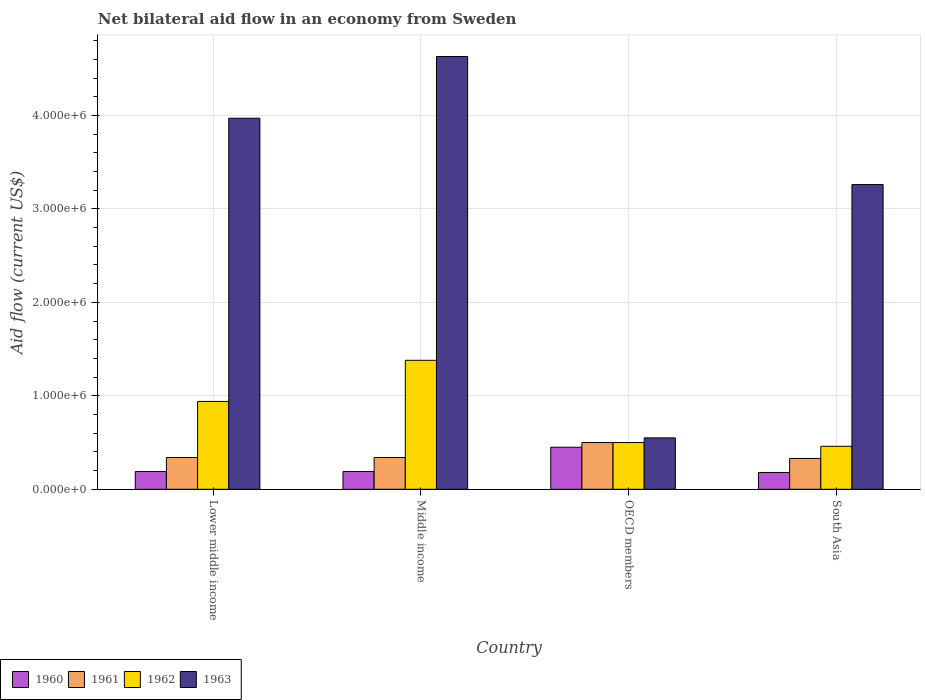How many different coloured bars are there?
Keep it short and to the point. 4. How many groups of bars are there?
Make the answer very short. 4. Are the number of bars on each tick of the X-axis equal?
Give a very brief answer. Yes. How many bars are there on the 1st tick from the left?
Give a very brief answer. 4. How many bars are there on the 2nd tick from the right?
Offer a terse response. 4. What is the label of the 2nd group of bars from the left?
Your answer should be compact. Middle income. Across all countries, what is the maximum net bilateral aid flow in 1961?
Offer a very short reply. 5.00e+05. Across all countries, what is the minimum net bilateral aid flow in 1961?
Provide a short and direct response. 3.30e+05. In which country was the net bilateral aid flow in 1962 maximum?
Keep it short and to the point. Middle income. What is the total net bilateral aid flow in 1963 in the graph?
Make the answer very short. 1.24e+07. What is the difference between the net bilateral aid flow in 1963 in Lower middle income and that in Middle income?
Offer a very short reply. -6.60e+05. What is the average net bilateral aid flow in 1960 per country?
Ensure brevity in your answer.  2.52e+05. What is the ratio of the net bilateral aid flow in 1963 in Middle income to that in OECD members?
Make the answer very short. 8.42. What is the difference between the highest and the second highest net bilateral aid flow in 1963?
Offer a terse response. 1.37e+06. What is the difference between the highest and the lowest net bilateral aid flow in 1961?
Your response must be concise. 1.70e+05. In how many countries, is the net bilateral aid flow in 1963 greater than the average net bilateral aid flow in 1963 taken over all countries?
Your response must be concise. 3. What does the 4th bar from the left in OECD members represents?
Your answer should be very brief. 1963. What does the 2nd bar from the right in Middle income represents?
Offer a very short reply. 1962. What is the difference between two consecutive major ticks on the Y-axis?
Your answer should be compact. 1.00e+06. Does the graph contain any zero values?
Your answer should be compact. No. How many legend labels are there?
Keep it short and to the point. 4. What is the title of the graph?
Give a very brief answer. Net bilateral aid flow in an economy from Sweden. What is the label or title of the X-axis?
Provide a short and direct response. Country. What is the Aid flow (current US$) in 1960 in Lower middle income?
Provide a succinct answer. 1.90e+05. What is the Aid flow (current US$) of 1962 in Lower middle income?
Your response must be concise. 9.40e+05. What is the Aid flow (current US$) of 1963 in Lower middle income?
Keep it short and to the point. 3.97e+06. What is the Aid flow (current US$) of 1960 in Middle income?
Make the answer very short. 1.90e+05. What is the Aid flow (current US$) of 1962 in Middle income?
Give a very brief answer. 1.38e+06. What is the Aid flow (current US$) in 1963 in Middle income?
Make the answer very short. 4.63e+06. What is the Aid flow (current US$) of 1960 in OECD members?
Offer a terse response. 4.50e+05. What is the Aid flow (current US$) in 1961 in OECD members?
Offer a very short reply. 5.00e+05. What is the Aid flow (current US$) in 1960 in South Asia?
Offer a very short reply. 1.80e+05. What is the Aid flow (current US$) in 1961 in South Asia?
Your response must be concise. 3.30e+05. What is the Aid flow (current US$) of 1963 in South Asia?
Your answer should be compact. 3.26e+06. Across all countries, what is the maximum Aid flow (current US$) of 1961?
Your response must be concise. 5.00e+05. Across all countries, what is the maximum Aid flow (current US$) of 1962?
Make the answer very short. 1.38e+06. Across all countries, what is the maximum Aid flow (current US$) in 1963?
Ensure brevity in your answer.  4.63e+06. Across all countries, what is the minimum Aid flow (current US$) of 1960?
Keep it short and to the point. 1.80e+05. Across all countries, what is the minimum Aid flow (current US$) in 1962?
Provide a succinct answer. 4.60e+05. Across all countries, what is the minimum Aid flow (current US$) of 1963?
Offer a terse response. 5.50e+05. What is the total Aid flow (current US$) in 1960 in the graph?
Your answer should be compact. 1.01e+06. What is the total Aid flow (current US$) of 1961 in the graph?
Provide a short and direct response. 1.51e+06. What is the total Aid flow (current US$) of 1962 in the graph?
Give a very brief answer. 3.28e+06. What is the total Aid flow (current US$) of 1963 in the graph?
Offer a very short reply. 1.24e+07. What is the difference between the Aid flow (current US$) in 1960 in Lower middle income and that in Middle income?
Your response must be concise. 0. What is the difference between the Aid flow (current US$) in 1962 in Lower middle income and that in Middle income?
Provide a short and direct response. -4.40e+05. What is the difference between the Aid flow (current US$) in 1963 in Lower middle income and that in Middle income?
Provide a short and direct response. -6.60e+05. What is the difference between the Aid flow (current US$) in 1960 in Lower middle income and that in OECD members?
Give a very brief answer. -2.60e+05. What is the difference between the Aid flow (current US$) in 1961 in Lower middle income and that in OECD members?
Your response must be concise. -1.60e+05. What is the difference between the Aid flow (current US$) of 1962 in Lower middle income and that in OECD members?
Keep it short and to the point. 4.40e+05. What is the difference between the Aid flow (current US$) in 1963 in Lower middle income and that in OECD members?
Keep it short and to the point. 3.42e+06. What is the difference between the Aid flow (current US$) in 1960 in Lower middle income and that in South Asia?
Give a very brief answer. 10000. What is the difference between the Aid flow (current US$) in 1961 in Lower middle income and that in South Asia?
Provide a succinct answer. 10000. What is the difference between the Aid flow (current US$) of 1963 in Lower middle income and that in South Asia?
Keep it short and to the point. 7.10e+05. What is the difference between the Aid flow (current US$) of 1960 in Middle income and that in OECD members?
Your response must be concise. -2.60e+05. What is the difference between the Aid flow (current US$) in 1961 in Middle income and that in OECD members?
Provide a succinct answer. -1.60e+05. What is the difference between the Aid flow (current US$) in 1962 in Middle income and that in OECD members?
Provide a succinct answer. 8.80e+05. What is the difference between the Aid flow (current US$) in 1963 in Middle income and that in OECD members?
Provide a succinct answer. 4.08e+06. What is the difference between the Aid flow (current US$) of 1961 in Middle income and that in South Asia?
Your answer should be compact. 10000. What is the difference between the Aid flow (current US$) in 1962 in Middle income and that in South Asia?
Your answer should be compact. 9.20e+05. What is the difference between the Aid flow (current US$) in 1963 in Middle income and that in South Asia?
Give a very brief answer. 1.37e+06. What is the difference between the Aid flow (current US$) of 1962 in OECD members and that in South Asia?
Offer a very short reply. 4.00e+04. What is the difference between the Aid flow (current US$) of 1963 in OECD members and that in South Asia?
Make the answer very short. -2.71e+06. What is the difference between the Aid flow (current US$) in 1960 in Lower middle income and the Aid flow (current US$) in 1962 in Middle income?
Your answer should be compact. -1.19e+06. What is the difference between the Aid flow (current US$) in 1960 in Lower middle income and the Aid flow (current US$) in 1963 in Middle income?
Ensure brevity in your answer.  -4.44e+06. What is the difference between the Aid flow (current US$) of 1961 in Lower middle income and the Aid flow (current US$) of 1962 in Middle income?
Offer a very short reply. -1.04e+06. What is the difference between the Aid flow (current US$) in 1961 in Lower middle income and the Aid flow (current US$) in 1963 in Middle income?
Your answer should be compact. -4.29e+06. What is the difference between the Aid flow (current US$) of 1962 in Lower middle income and the Aid flow (current US$) of 1963 in Middle income?
Make the answer very short. -3.69e+06. What is the difference between the Aid flow (current US$) in 1960 in Lower middle income and the Aid flow (current US$) in 1961 in OECD members?
Your response must be concise. -3.10e+05. What is the difference between the Aid flow (current US$) of 1960 in Lower middle income and the Aid flow (current US$) of 1962 in OECD members?
Provide a short and direct response. -3.10e+05. What is the difference between the Aid flow (current US$) in 1960 in Lower middle income and the Aid flow (current US$) in 1963 in OECD members?
Provide a short and direct response. -3.60e+05. What is the difference between the Aid flow (current US$) in 1961 in Lower middle income and the Aid flow (current US$) in 1962 in OECD members?
Provide a short and direct response. -1.60e+05. What is the difference between the Aid flow (current US$) of 1960 in Lower middle income and the Aid flow (current US$) of 1961 in South Asia?
Provide a short and direct response. -1.40e+05. What is the difference between the Aid flow (current US$) in 1960 in Lower middle income and the Aid flow (current US$) in 1963 in South Asia?
Ensure brevity in your answer.  -3.07e+06. What is the difference between the Aid flow (current US$) in 1961 in Lower middle income and the Aid flow (current US$) in 1962 in South Asia?
Ensure brevity in your answer.  -1.20e+05. What is the difference between the Aid flow (current US$) in 1961 in Lower middle income and the Aid flow (current US$) in 1963 in South Asia?
Ensure brevity in your answer.  -2.92e+06. What is the difference between the Aid flow (current US$) in 1962 in Lower middle income and the Aid flow (current US$) in 1963 in South Asia?
Offer a terse response. -2.32e+06. What is the difference between the Aid flow (current US$) in 1960 in Middle income and the Aid flow (current US$) in 1961 in OECD members?
Your answer should be very brief. -3.10e+05. What is the difference between the Aid flow (current US$) in 1960 in Middle income and the Aid flow (current US$) in 1962 in OECD members?
Keep it short and to the point. -3.10e+05. What is the difference between the Aid flow (current US$) in 1960 in Middle income and the Aid flow (current US$) in 1963 in OECD members?
Make the answer very short. -3.60e+05. What is the difference between the Aid flow (current US$) in 1962 in Middle income and the Aid flow (current US$) in 1963 in OECD members?
Your answer should be compact. 8.30e+05. What is the difference between the Aid flow (current US$) in 1960 in Middle income and the Aid flow (current US$) in 1962 in South Asia?
Provide a succinct answer. -2.70e+05. What is the difference between the Aid flow (current US$) in 1960 in Middle income and the Aid flow (current US$) in 1963 in South Asia?
Ensure brevity in your answer.  -3.07e+06. What is the difference between the Aid flow (current US$) of 1961 in Middle income and the Aid flow (current US$) of 1962 in South Asia?
Offer a very short reply. -1.20e+05. What is the difference between the Aid flow (current US$) in 1961 in Middle income and the Aid flow (current US$) in 1963 in South Asia?
Give a very brief answer. -2.92e+06. What is the difference between the Aid flow (current US$) of 1962 in Middle income and the Aid flow (current US$) of 1963 in South Asia?
Offer a very short reply. -1.88e+06. What is the difference between the Aid flow (current US$) in 1960 in OECD members and the Aid flow (current US$) in 1962 in South Asia?
Keep it short and to the point. -10000. What is the difference between the Aid flow (current US$) of 1960 in OECD members and the Aid flow (current US$) of 1963 in South Asia?
Your response must be concise. -2.81e+06. What is the difference between the Aid flow (current US$) of 1961 in OECD members and the Aid flow (current US$) of 1962 in South Asia?
Your answer should be compact. 4.00e+04. What is the difference between the Aid flow (current US$) in 1961 in OECD members and the Aid flow (current US$) in 1963 in South Asia?
Provide a short and direct response. -2.76e+06. What is the difference between the Aid flow (current US$) of 1962 in OECD members and the Aid flow (current US$) of 1963 in South Asia?
Offer a very short reply. -2.76e+06. What is the average Aid flow (current US$) of 1960 per country?
Offer a very short reply. 2.52e+05. What is the average Aid flow (current US$) in 1961 per country?
Your response must be concise. 3.78e+05. What is the average Aid flow (current US$) of 1962 per country?
Keep it short and to the point. 8.20e+05. What is the average Aid flow (current US$) in 1963 per country?
Provide a short and direct response. 3.10e+06. What is the difference between the Aid flow (current US$) of 1960 and Aid flow (current US$) of 1962 in Lower middle income?
Offer a very short reply. -7.50e+05. What is the difference between the Aid flow (current US$) of 1960 and Aid flow (current US$) of 1963 in Lower middle income?
Provide a succinct answer. -3.78e+06. What is the difference between the Aid flow (current US$) of 1961 and Aid flow (current US$) of 1962 in Lower middle income?
Give a very brief answer. -6.00e+05. What is the difference between the Aid flow (current US$) in 1961 and Aid flow (current US$) in 1963 in Lower middle income?
Your response must be concise. -3.63e+06. What is the difference between the Aid flow (current US$) in 1962 and Aid flow (current US$) in 1963 in Lower middle income?
Keep it short and to the point. -3.03e+06. What is the difference between the Aid flow (current US$) of 1960 and Aid flow (current US$) of 1962 in Middle income?
Give a very brief answer. -1.19e+06. What is the difference between the Aid flow (current US$) of 1960 and Aid flow (current US$) of 1963 in Middle income?
Provide a succinct answer. -4.44e+06. What is the difference between the Aid flow (current US$) in 1961 and Aid flow (current US$) in 1962 in Middle income?
Make the answer very short. -1.04e+06. What is the difference between the Aid flow (current US$) of 1961 and Aid flow (current US$) of 1963 in Middle income?
Your response must be concise. -4.29e+06. What is the difference between the Aid flow (current US$) in 1962 and Aid flow (current US$) in 1963 in Middle income?
Give a very brief answer. -3.25e+06. What is the difference between the Aid flow (current US$) in 1960 and Aid flow (current US$) in 1963 in OECD members?
Offer a terse response. -1.00e+05. What is the difference between the Aid flow (current US$) of 1961 and Aid flow (current US$) of 1963 in OECD members?
Offer a terse response. -5.00e+04. What is the difference between the Aid flow (current US$) of 1960 and Aid flow (current US$) of 1962 in South Asia?
Keep it short and to the point. -2.80e+05. What is the difference between the Aid flow (current US$) in 1960 and Aid flow (current US$) in 1963 in South Asia?
Offer a terse response. -3.08e+06. What is the difference between the Aid flow (current US$) of 1961 and Aid flow (current US$) of 1962 in South Asia?
Your answer should be compact. -1.30e+05. What is the difference between the Aid flow (current US$) of 1961 and Aid flow (current US$) of 1963 in South Asia?
Offer a terse response. -2.93e+06. What is the difference between the Aid flow (current US$) in 1962 and Aid flow (current US$) in 1963 in South Asia?
Ensure brevity in your answer.  -2.80e+06. What is the ratio of the Aid flow (current US$) in 1960 in Lower middle income to that in Middle income?
Offer a very short reply. 1. What is the ratio of the Aid flow (current US$) of 1962 in Lower middle income to that in Middle income?
Give a very brief answer. 0.68. What is the ratio of the Aid flow (current US$) in 1963 in Lower middle income to that in Middle income?
Your answer should be very brief. 0.86. What is the ratio of the Aid flow (current US$) in 1960 in Lower middle income to that in OECD members?
Provide a short and direct response. 0.42. What is the ratio of the Aid flow (current US$) of 1961 in Lower middle income to that in OECD members?
Offer a very short reply. 0.68. What is the ratio of the Aid flow (current US$) in 1962 in Lower middle income to that in OECD members?
Your answer should be very brief. 1.88. What is the ratio of the Aid flow (current US$) in 1963 in Lower middle income to that in OECD members?
Give a very brief answer. 7.22. What is the ratio of the Aid flow (current US$) of 1960 in Lower middle income to that in South Asia?
Provide a short and direct response. 1.06. What is the ratio of the Aid flow (current US$) in 1961 in Lower middle income to that in South Asia?
Your answer should be very brief. 1.03. What is the ratio of the Aid flow (current US$) of 1962 in Lower middle income to that in South Asia?
Make the answer very short. 2.04. What is the ratio of the Aid flow (current US$) in 1963 in Lower middle income to that in South Asia?
Ensure brevity in your answer.  1.22. What is the ratio of the Aid flow (current US$) of 1960 in Middle income to that in OECD members?
Give a very brief answer. 0.42. What is the ratio of the Aid flow (current US$) in 1961 in Middle income to that in OECD members?
Ensure brevity in your answer.  0.68. What is the ratio of the Aid flow (current US$) in 1962 in Middle income to that in OECD members?
Your answer should be compact. 2.76. What is the ratio of the Aid flow (current US$) of 1963 in Middle income to that in OECD members?
Your response must be concise. 8.42. What is the ratio of the Aid flow (current US$) of 1960 in Middle income to that in South Asia?
Provide a succinct answer. 1.06. What is the ratio of the Aid flow (current US$) in 1961 in Middle income to that in South Asia?
Give a very brief answer. 1.03. What is the ratio of the Aid flow (current US$) in 1962 in Middle income to that in South Asia?
Your answer should be compact. 3. What is the ratio of the Aid flow (current US$) in 1963 in Middle income to that in South Asia?
Ensure brevity in your answer.  1.42. What is the ratio of the Aid flow (current US$) in 1960 in OECD members to that in South Asia?
Provide a short and direct response. 2.5. What is the ratio of the Aid flow (current US$) in 1961 in OECD members to that in South Asia?
Keep it short and to the point. 1.52. What is the ratio of the Aid flow (current US$) of 1962 in OECD members to that in South Asia?
Your answer should be compact. 1.09. What is the ratio of the Aid flow (current US$) of 1963 in OECD members to that in South Asia?
Offer a terse response. 0.17. What is the difference between the highest and the second highest Aid flow (current US$) of 1962?
Offer a very short reply. 4.40e+05. What is the difference between the highest and the lowest Aid flow (current US$) in 1961?
Your answer should be very brief. 1.70e+05. What is the difference between the highest and the lowest Aid flow (current US$) of 1962?
Make the answer very short. 9.20e+05. What is the difference between the highest and the lowest Aid flow (current US$) of 1963?
Offer a very short reply. 4.08e+06. 